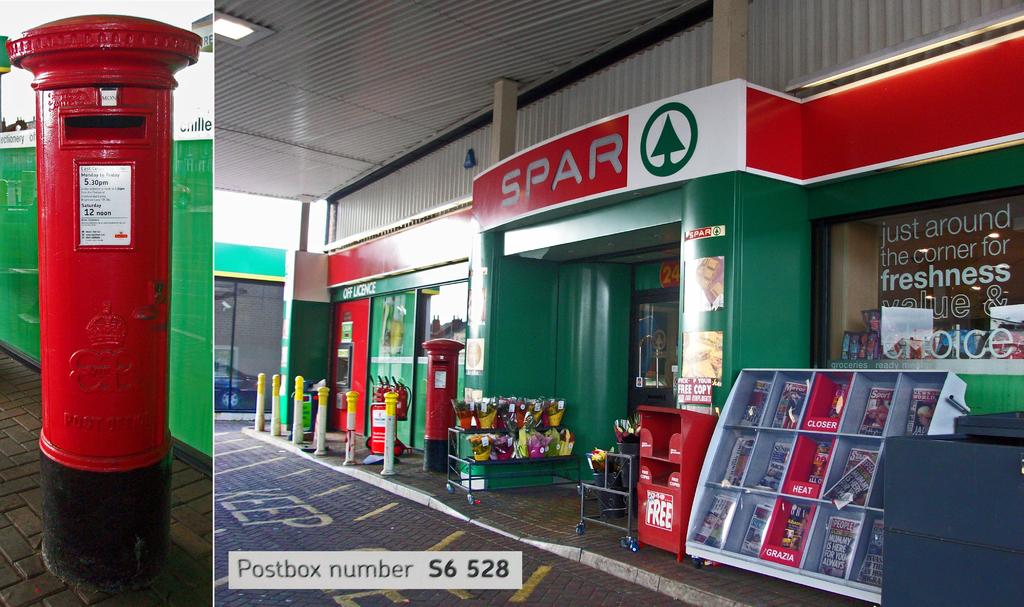What is the postbox's number?
Provide a short and direct response. S6 528. What's just around the corner?
Make the answer very short. Spar. 